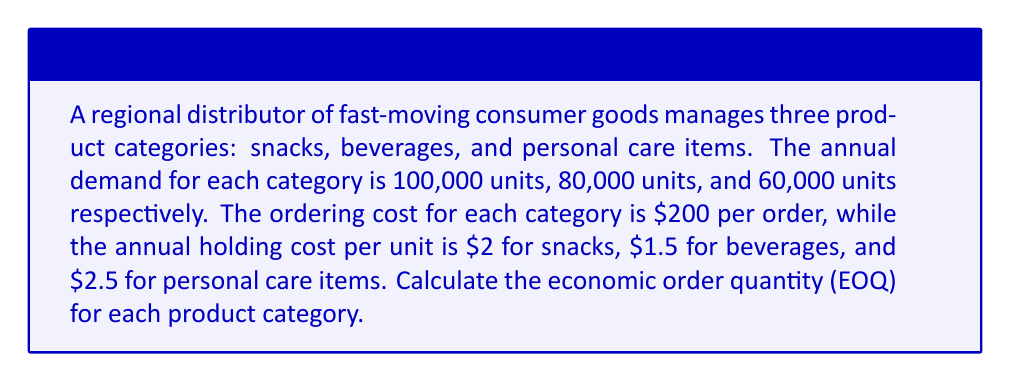Could you help me with this problem? To calculate the Economic Order Quantity (EOQ) for each product category, we'll use the EOQ formula:

$$ EOQ = \sqrt{\frac{2DS}{H}} $$

Where:
$D$ = Annual demand
$S$ = Ordering cost per order
$H$ = Annual holding cost per unit

For each product category:

1. Snacks:
   $D = 100,000$ units
   $S = \$200$ per order
   $H = \$2$ per unit per year

   $$ EOQ_{snacks} = \sqrt{\frac{2 \times 100,000 \times 200}{2}} = \sqrt{20,000,000} = 4,472.14 \text{ units} $$

2. Beverages:
   $D = 80,000$ units
   $S = \$200$ per order
   $H = \$1.5$ per unit per year

   $$ EOQ_{beverages} = \sqrt{\frac{2 \times 80,000 \times 200}{1.5}} = \sqrt{21,333,333.33} = 4,618.80 \text{ units} $$

3. Personal Care Items:
   $D = 60,000$ units
   $S = \$200$ per order
   $H = \$2.5$ per unit per year

   $$ EOQ_{personal care} = \sqrt{\frac{2 \times 60,000 \times 200}{2.5}} = \sqrt{9,600,000} = 3,098.39 \text{ units} $$

The EOQ represents the optimal order quantity that minimizes total inventory costs, balancing ordering costs and holding costs.
Answer: The Economic Order Quantities for each product category are:
Snacks: 4,472 units
Beverages: 4,619 units
Personal Care Items: 3,098 units 